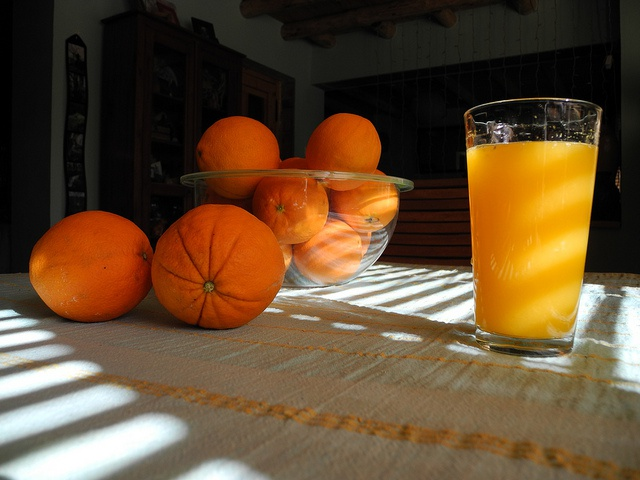Describe the objects in this image and their specific colors. I can see dining table in black, gray, white, and olive tones, cup in black, orange, and red tones, bowl in black, red, orange, and maroon tones, orange in black, maroon, red, and brown tones, and orange in black, brown, red, and maroon tones in this image. 